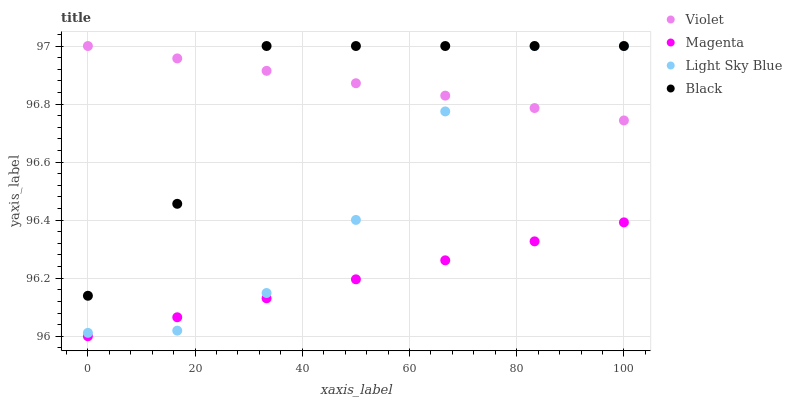Does Magenta have the minimum area under the curve?
Answer yes or no. Yes. Does Violet have the maximum area under the curve?
Answer yes or no. Yes. Does Light Sky Blue have the minimum area under the curve?
Answer yes or no. No. Does Light Sky Blue have the maximum area under the curve?
Answer yes or no. No. Is Violet the smoothest?
Answer yes or no. Yes. Is Black the roughest?
Answer yes or no. Yes. Is Light Sky Blue the smoothest?
Answer yes or no. No. Is Light Sky Blue the roughest?
Answer yes or no. No. Does Magenta have the lowest value?
Answer yes or no. Yes. Does Light Sky Blue have the lowest value?
Answer yes or no. No. Does Violet have the highest value?
Answer yes or no. Yes. Is Magenta less than Violet?
Answer yes or no. Yes. Is Violet greater than Magenta?
Answer yes or no. Yes. Does Violet intersect Light Sky Blue?
Answer yes or no. Yes. Is Violet less than Light Sky Blue?
Answer yes or no. No. Is Violet greater than Light Sky Blue?
Answer yes or no. No. Does Magenta intersect Violet?
Answer yes or no. No. 